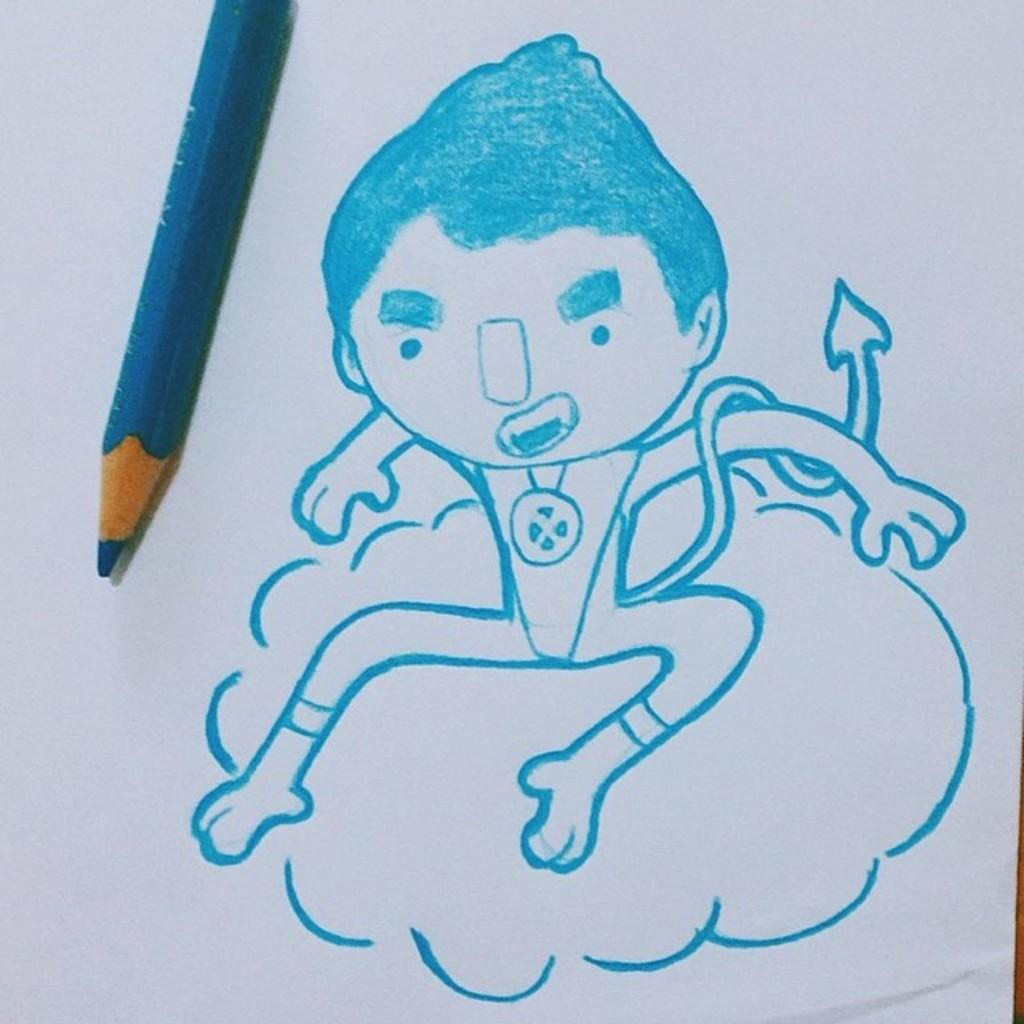What is the primary object in the image? There is a white paper in the image. What is depicted on the paper? There is a sketch on the paper. What color pencil is present on the paper? There is a sky blue color pencil on the paper. What type of lock is used to secure the end of the color pencil in the image? There is no lock present in the image, and the color pencil is not secured to the paper. 